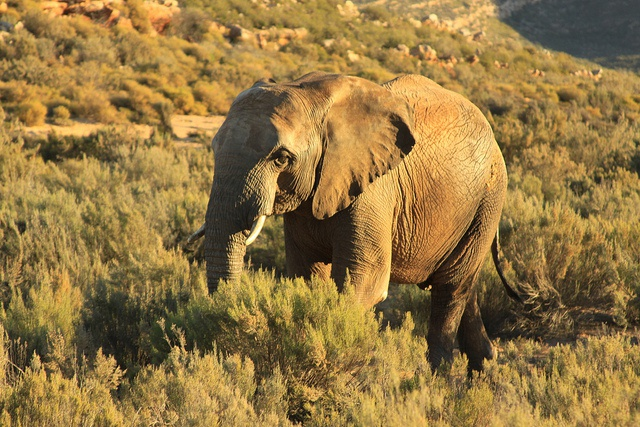Describe the objects in this image and their specific colors. I can see a elephant in orange, black, gray, and olive tones in this image. 